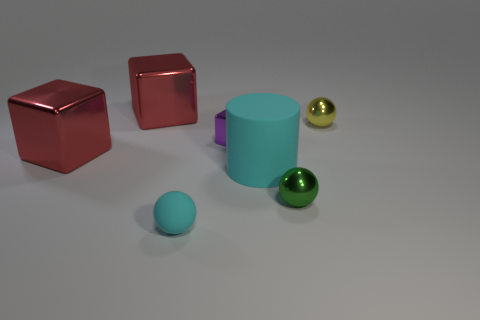Does the tiny ball that is on the left side of the purple object have the same color as the matte cylinder?
Provide a succinct answer. Yes. How many other objects are the same color as the big matte cylinder?
Offer a very short reply. 1. What color is the tiny object that is behind the tiny green thing and in front of the yellow shiny thing?
Your answer should be very brief. Purple. What number of tiny purple matte cylinders are there?
Your answer should be very brief. 0. Is the material of the big cyan thing the same as the green thing?
Provide a short and direct response. No. What is the shape of the red object that is on the right side of the large metallic object that is in front of the metallic sphere that is on the right side of the green object?
Your answer should be compact. Cube. Does the sphere that is behind the tiny cube have the same material as the big red object that is behind the purple metallic object?
Your response must be concise. Yes. What material is the small green ball?
Offer a terse response. Metal. How many small matte objects are the same shape as the tiny purple metal thing?
Provide a succinct answer. 0. Is there any other thing that has the same shape as the purple shiny thing?
Give a very brief answer. Yes. 